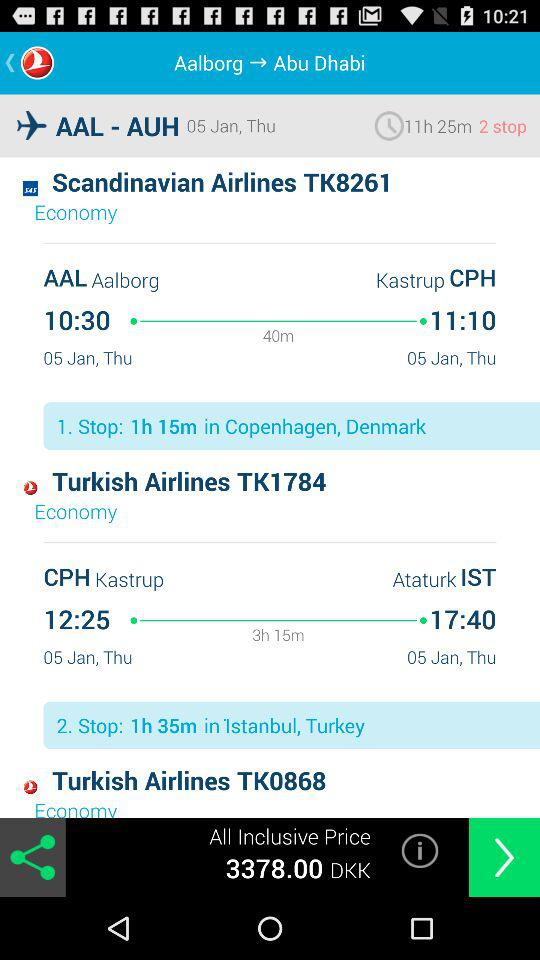Which class is selected in "Scandinavian Airlines TK8261"? The class that is selected in "Scandinavian Airlines TK8261" is "Economy". 